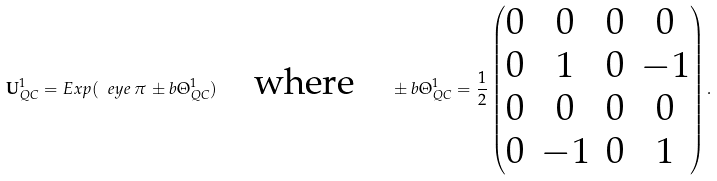Convert formula to latex. <formula><loc_0><loc_0><loc_500><loc_500>\mathbf U _ { Q C } ^ { 1 } = E x p ( \ e y e \, \pi \, \pm b \Theta _ { Q C } ^ { 1 } ) \quad \text {where} \quad \pm b \Theta _ { Q C } ^ { 1 } = \frac { 1 } { 2 } \begin{pmatrix} 0 & 0 & 0 & 0 \\ 0 & 1 & 0 & - 1 \\ 0 & 0 & 0 & 0 \\ 0 & - 1 & 0 & 1 \end{pmatrix} .</formula> 